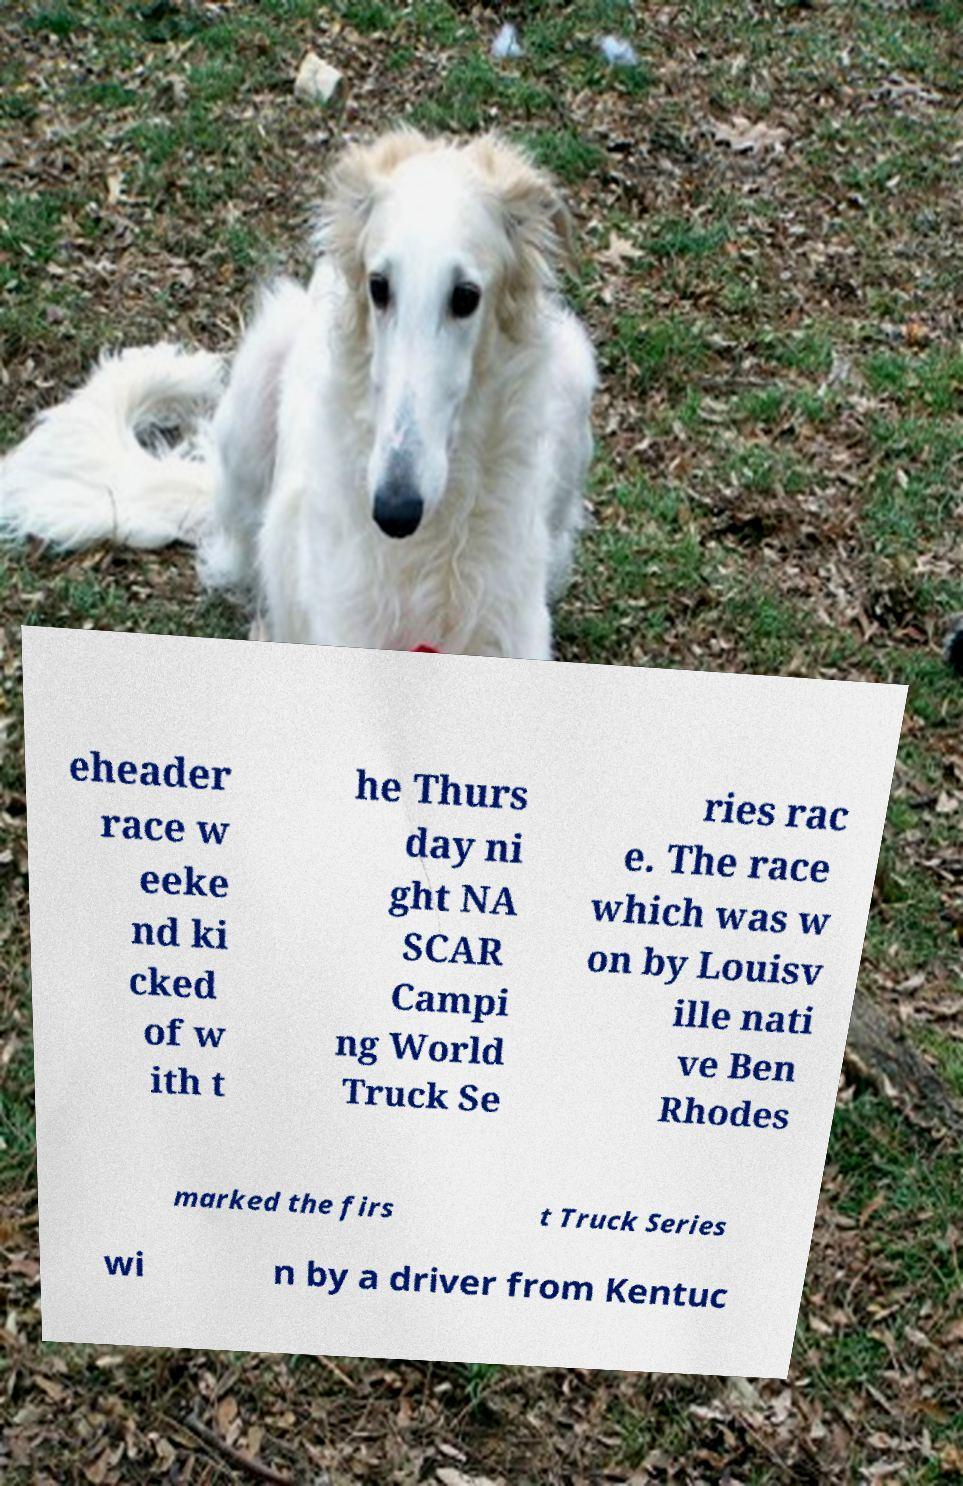Can you accurately transcribe the text from the provided image for me? eheader race w eeke nd ki cked of w ith t he Thurs day ni ght NA SCAR Campi ng World Truck Se ries rac e. The race which was w on by Louisv ille nati ve Ben Rhodes marked the firs t Truck Series wi n by a driver from Kentuc 